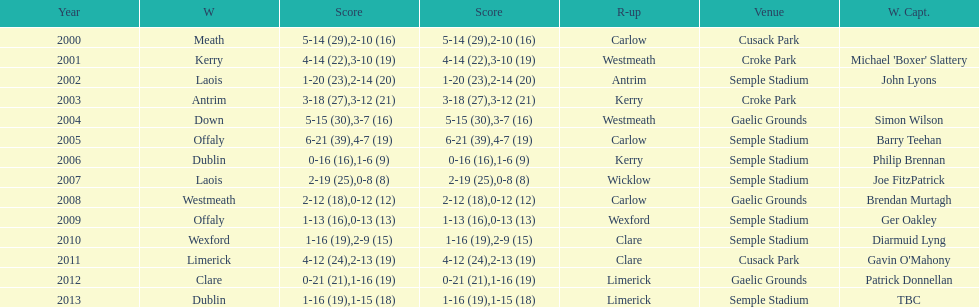Which team was the first to win with a team captain? Kerry. 